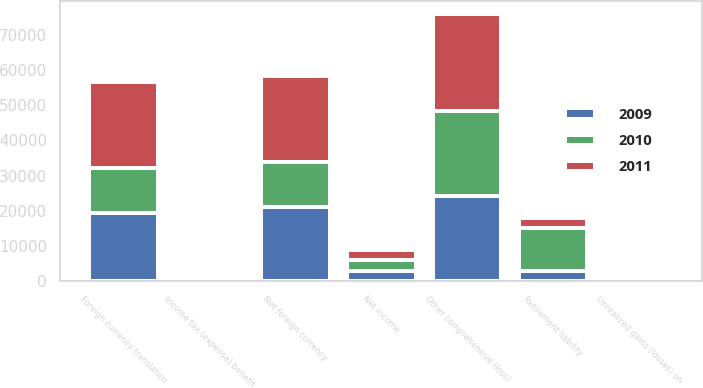Convert chart. <chart><loc_0><loc_0><loc_500><loc_500><stacked_bar_chart><ecel><fcel>Net income<fcel>Foreign currency translation<fcel>Net foreign currency<fcel>Unrealized gains (losses) on<fcel>Income tax (expense) benefit<fcel>Retirement liability<fcel>Other comprehensive (loss)<nl><fcel>2010<fcel>2977<fcel>12644<fcel>12644<fcel>627<fcel>339<fcel>12243<fcel>24260<nl><fcel>2011<fcel>2977<fcel>24568<fcel>24568<fcel>12<fcel>7<fcel>2813<fcel>27369<nl><fcel>2009<fcel>2977<fcel>19405<fcel>21203<fcel>25<fcel>13<fcel>2977<fcel>24155<nl></chart> 